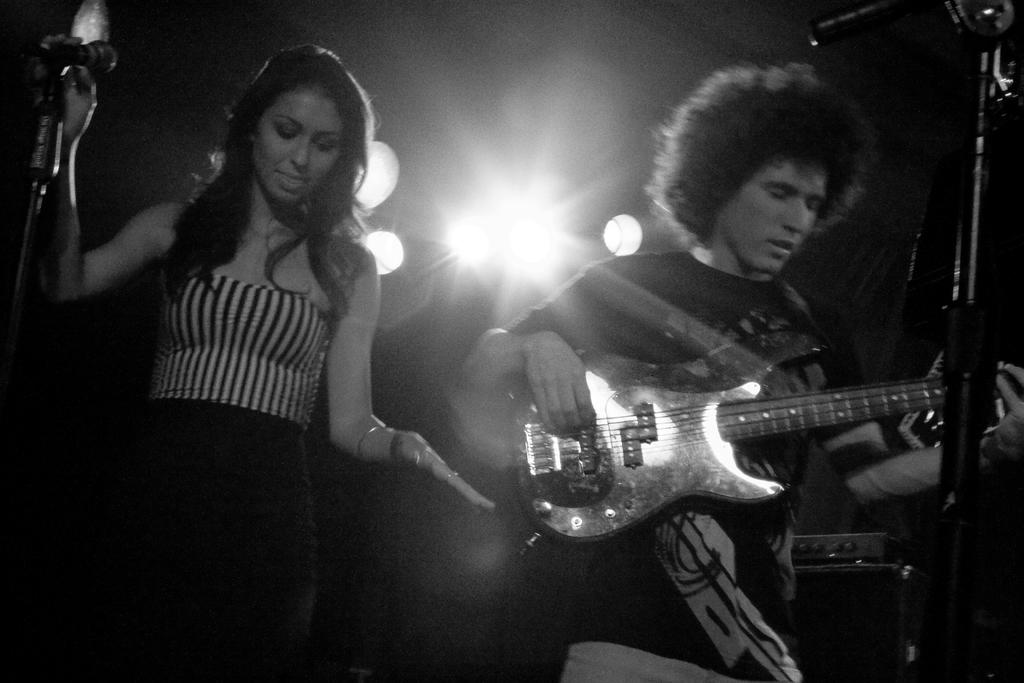Who are the people in the image? There is a woman and a man in the image. What is the man doing in the image? The man is playing a guitar. Where is the man positioned in relation to the microphone? The man is in front of a microphone. What can be seen in the background of the image? There are lights visible in the background of the image. What type of stick is the chicken holding in the image? There is no chicken or stick present in the image. What kind of noise can be heard coming from the microphone in the image? The image is a still photograph, so no sound or noise can be heard from the microphone. 